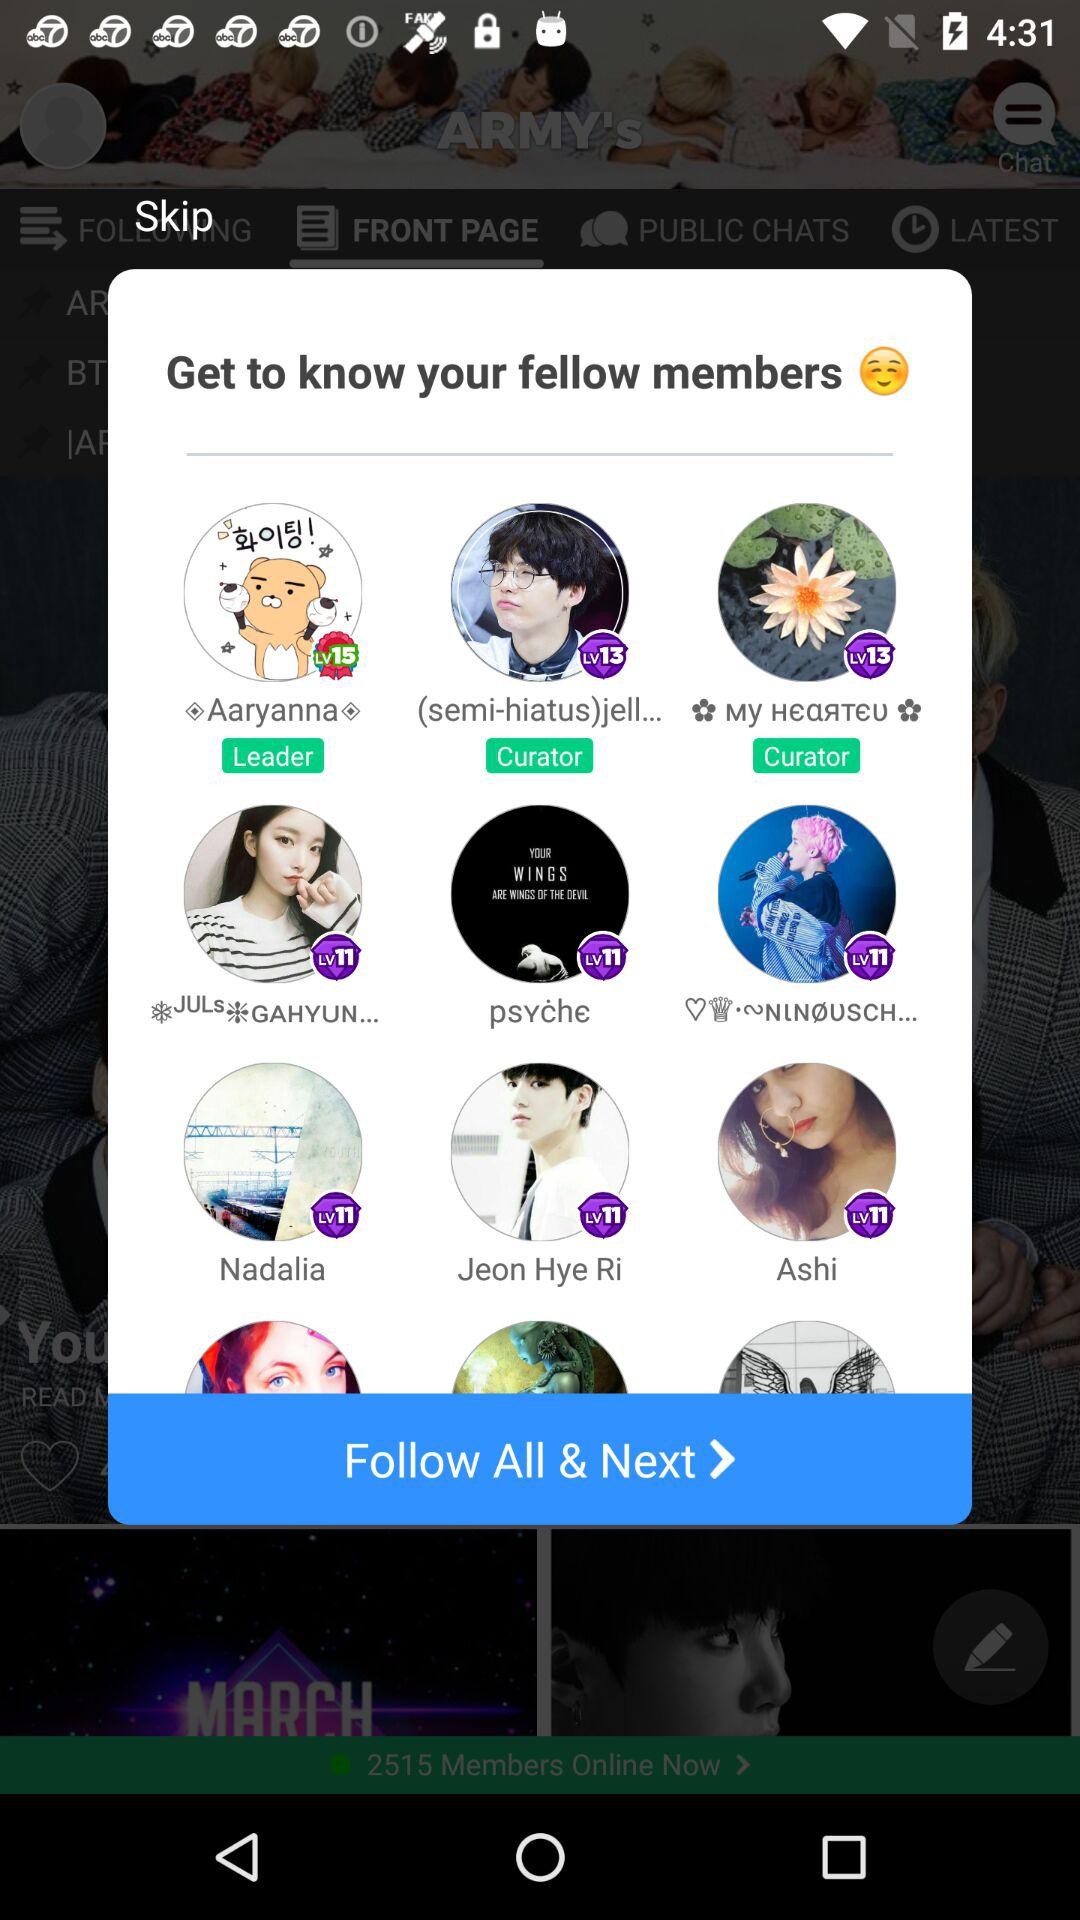What is the name of curator?
When the provided information is insufficient, respond with <no answer>. <no answer> 